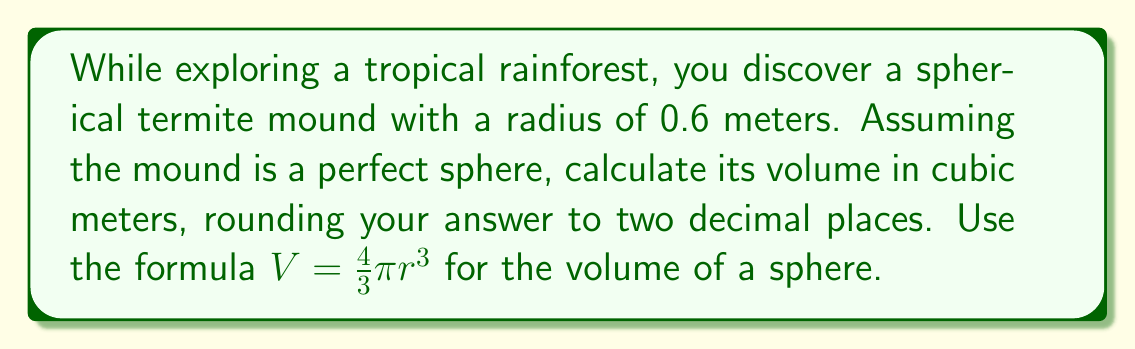Can you answer this question? Let's approach this step-by-step:

1) We are given the formula for the volume of a sphere:
   $V = \frac{4}{3}\pi r^3$

2) We know the radius $r = 0.6$ meters

3) Let's substitute this into our formula:
   $V = \frac{4}{3}\pi (0.6)^3$

4) Now, let's calculate the cube of 0.6:
   $(0.6)^3 = 0.6 \times 0.6 \times 0.6 = 0.216$

5) Substituting this back into our equation:
   $V = \frac{4}{3}\pi (0.216)$

6) Let's multiply:
   $V = \frac{4}{3} \times 3.14159... \times 0.216$

7) Calculating this:
   $V \approx 0.9047... \text{ cubic meters}$

8) Rounding to two decimal places:
   $V \approx 0.90 \text{ cubic meters}$
Answer: $0.90 \text{ m}^3$ 